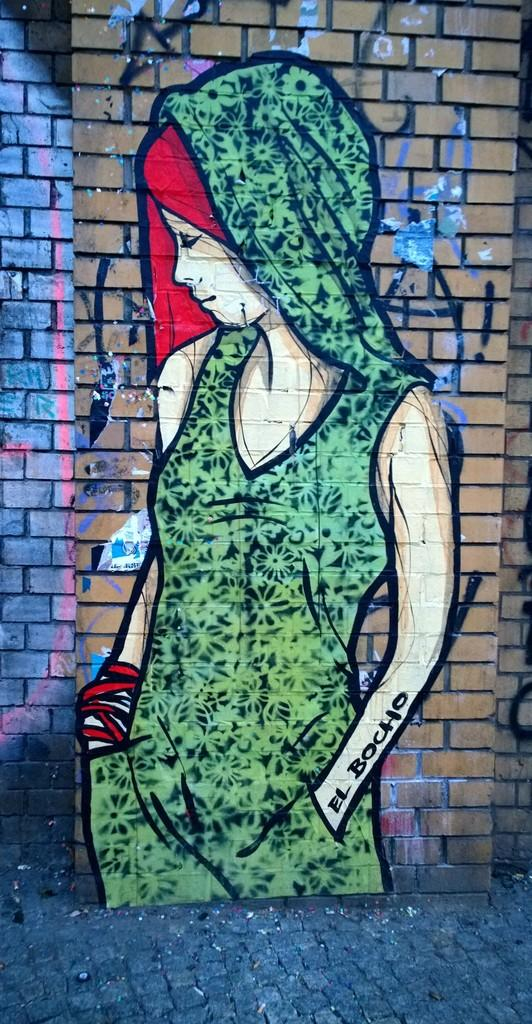What is depicted on the wall in the image? There is a painting of a girl on the wall. What color is the girl's dress in the painting? The girl's dress in the painting is green. How many kittens are sitting on the girl's lap in the painting? There are no kittens present in the painting; it depicts a girl with a green dress. 